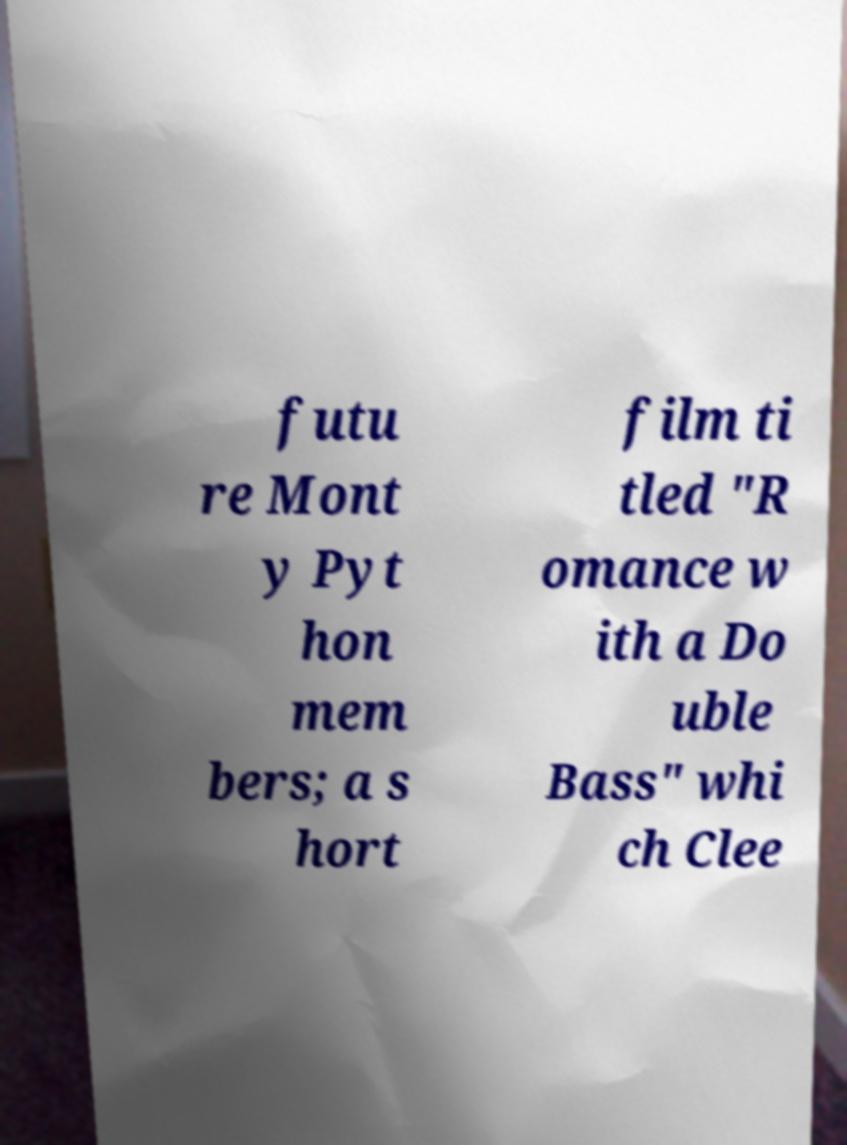Can you accurately transcribe the text from the provided image for me? futu re Mont y Pyt hon mem bers; a s hort film ti tled "R omance w ith a Do uble Bass" whi ch Clee 